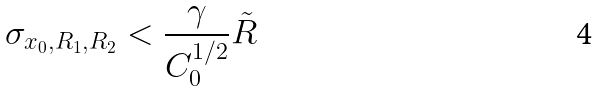Convert formula to latex. <formula><loc_0><loc_0><loc_500><loc_500>\sigma _ { x _ { 0 } , R _ { 1 } , R _ { 2 } } < \frac { \gamma } { C _ { 0 } ^ { 1 / 2 } } \tilde { R } \,</formula> 